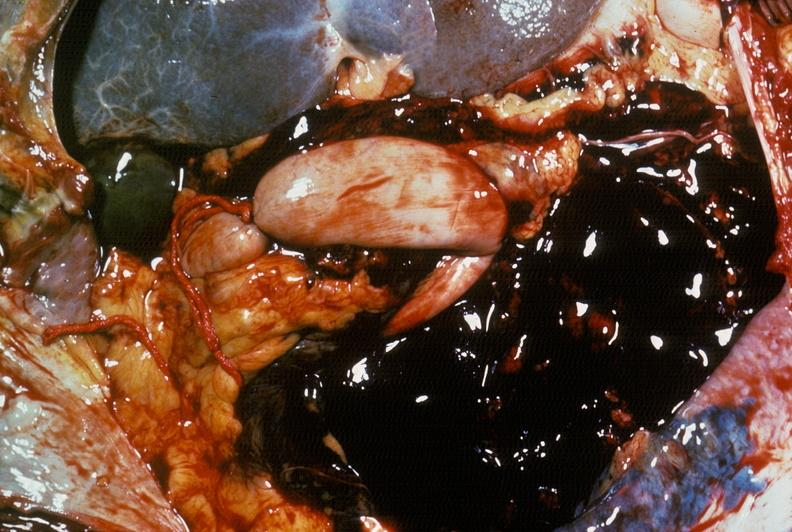what is present?
Answer the question using a single word or phrase. Abdomen 